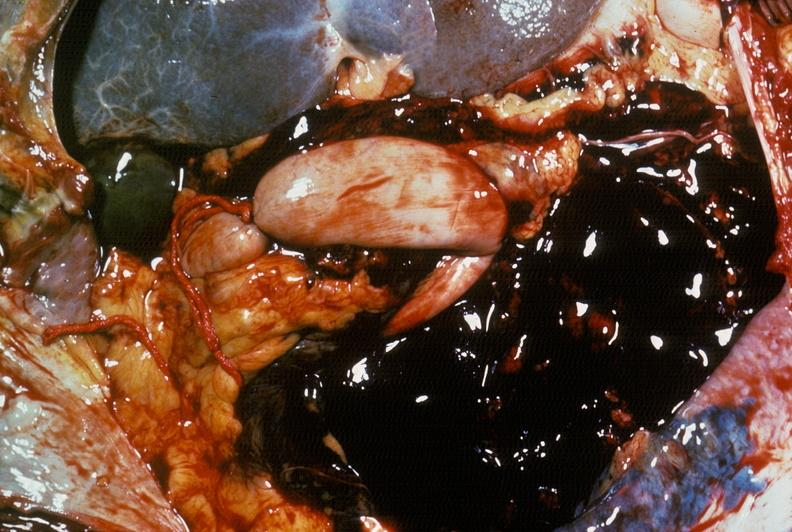what is present?
Answer the question using a single word or phrase. Abdomen 